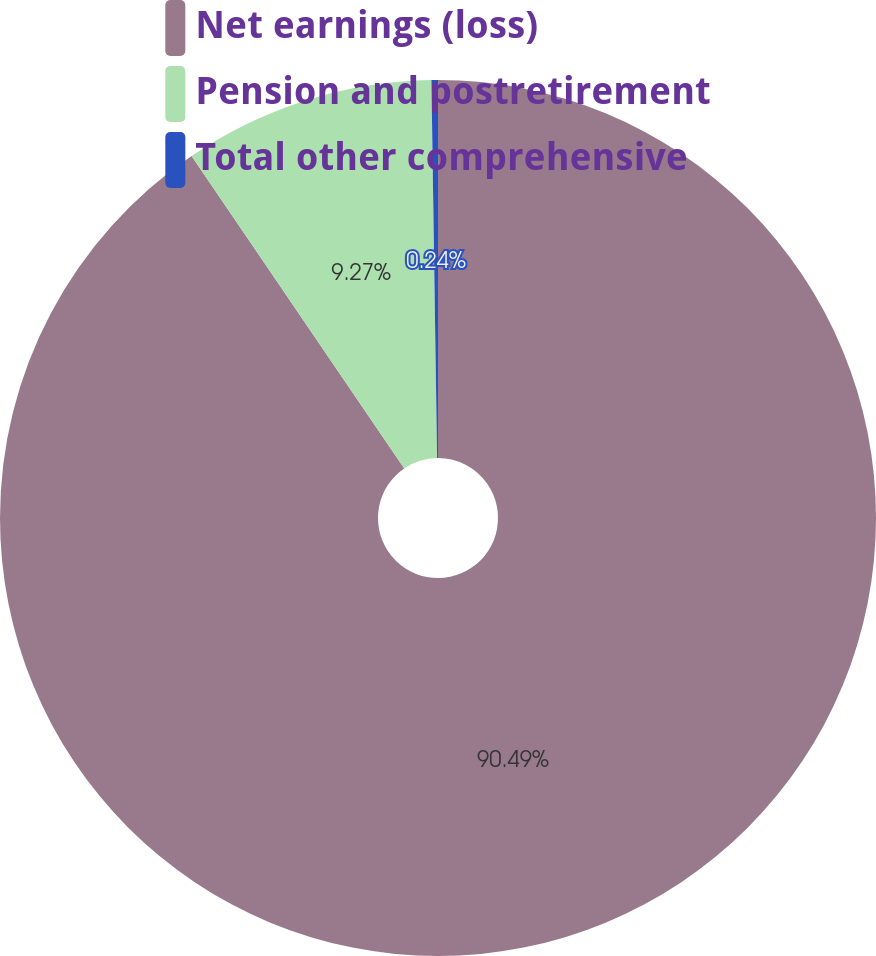Convert chart to OTSL. <chart><loc_0><loc_0><loc_500><loc_500><pie_chart><fcel>Net earnings (loss)<fcel>Pension and postretirement<fcel>Total other comprehensive<nl><fcel>90.49%<fcel>9.27%<fcel>0.24%<nl></chart> 